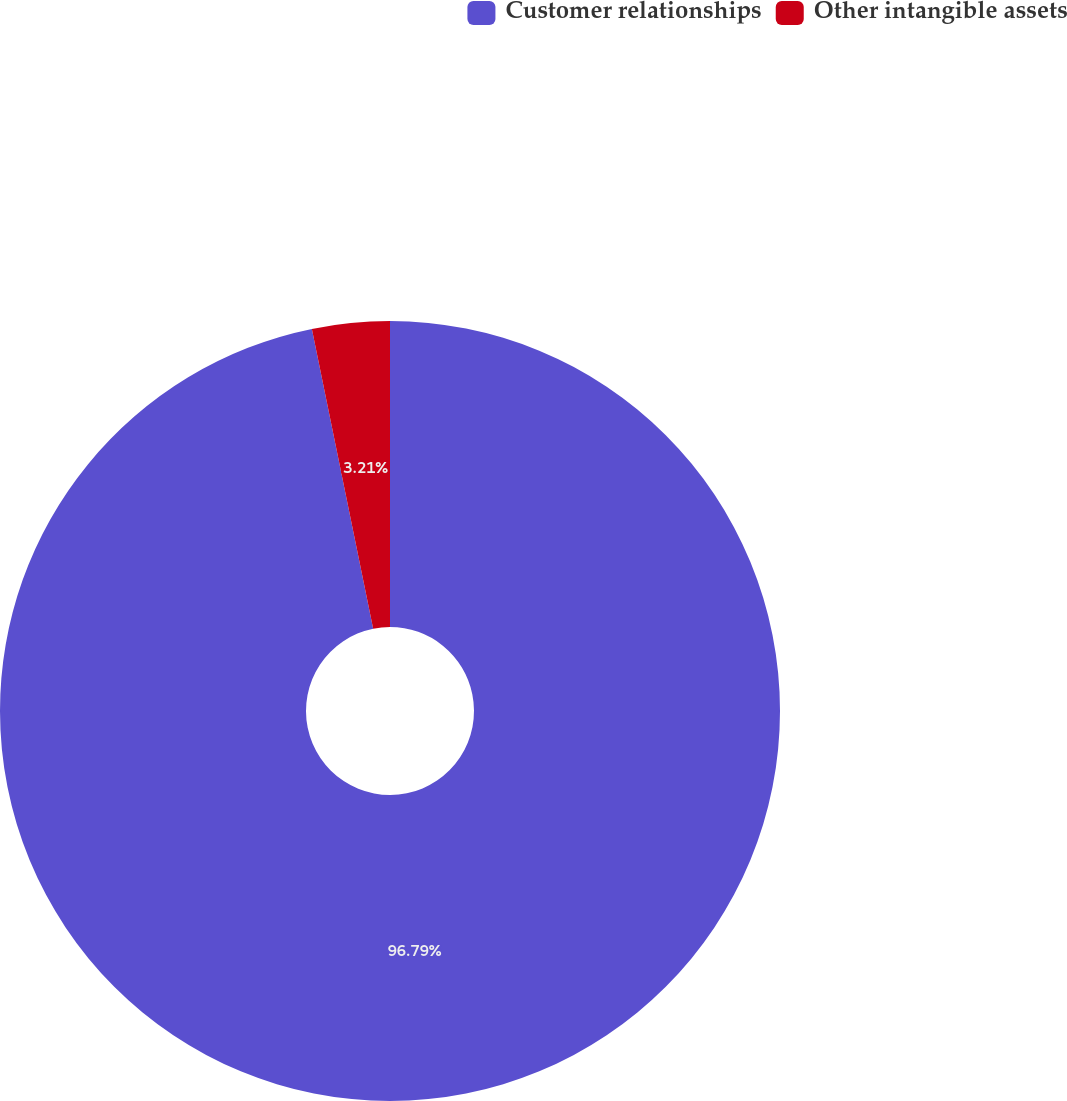Convert chart. <chart><loc_0><loc_0><loc_500><loc_500><pie_chart><fcel>Customer relationships<fcel>Other intangible assets<nl><fcel>96.79%<fcel>3.21%<nl></chart> 